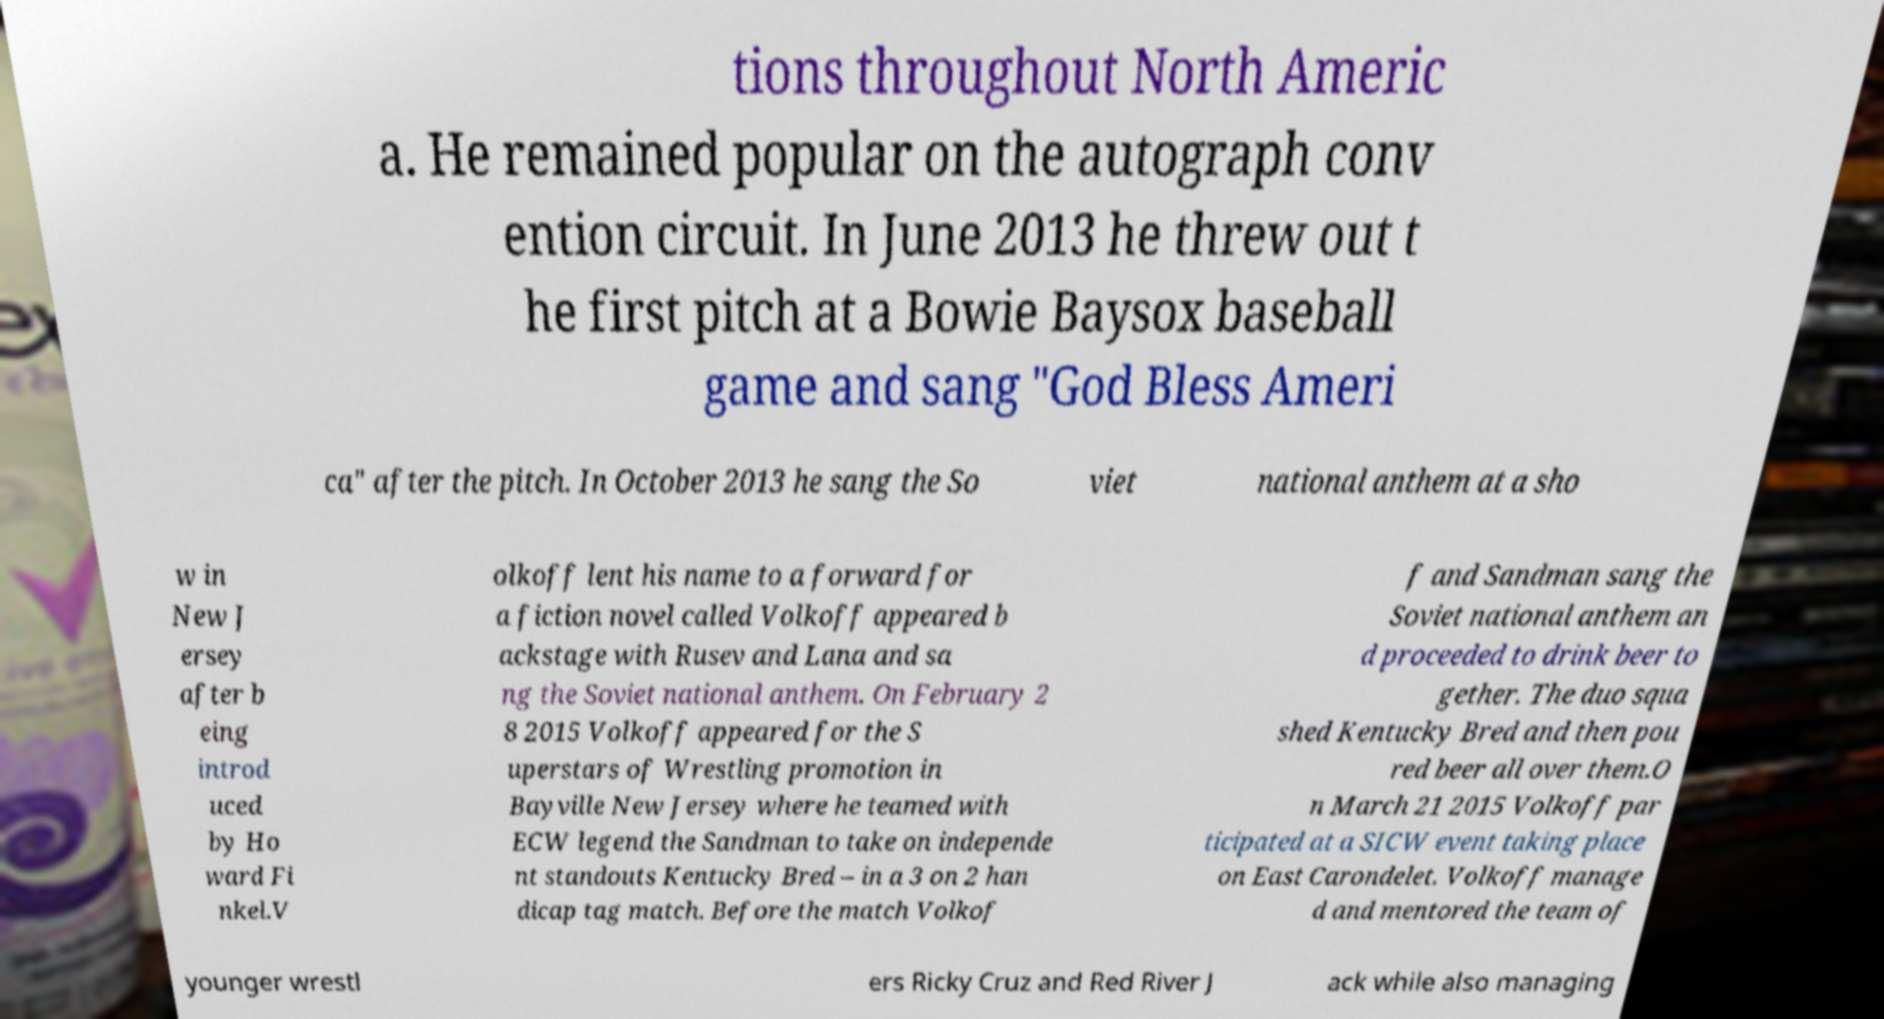Please identify and transcribe the text found in this image. tions throughout North Americ a. He remained popular on the autograph conv ention circuit. In June 2013 he threw out t he first pitch at a Bowie Baysox baseball game and sang "God Bless Ameri ca" after the pitch. In October 2013 he sang the So viet national anthem at a sho w in New J ersey after b eing introd uced by Ho ward Fi nkel.V olkoff lent his name to a forward for a fiction novel called Volkoff appeared b ackstage with Rusev and Lana and sa ng the Soviet national anthem. On February 2 8 2015 Volkoff appeared for the S uperstars of Wrestling promotion in Bayville New Jersey where he teamed with ECW legend the Sandman to take on independe nt standouts Kentucky Bred – in a 3 on 2 han dicap tag match. Before the match Volkof f and Sandman sang the Soviet national anthem an d proceeded to drink beer to gether. The duo squa shed Kentucky Bred and then pou red beer all over them.O n March 21 2015 Volkoff par ticipated at a SICW event taking place on East Carondelet. Volkoff manage d and mentored the team of younger wrestl ers Ricky Cruz and Red River J ack while also managing 